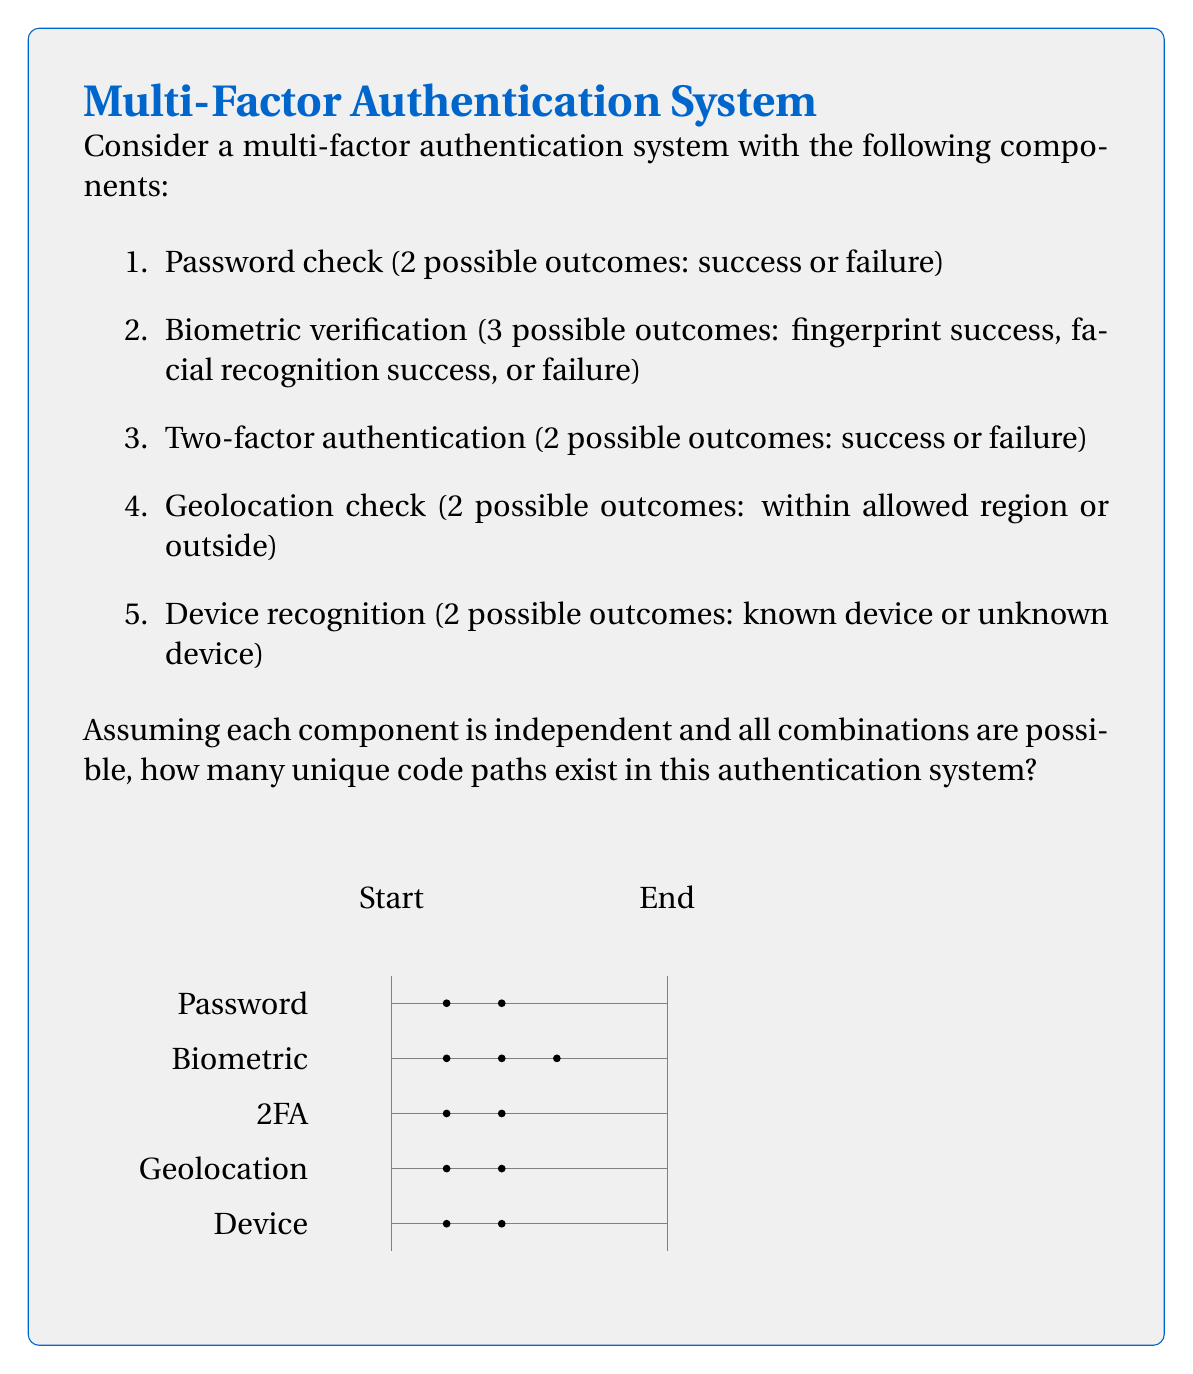Help me with this question. To solve this problem, we'll use the multiplication principle of combinatorics. Since each component is independent and all combinations are possible, we multiply the number of possible outcomes for each component:

1. Password check: 2 outcomes
2. Biometric verification: 3 outcomes
3. Two-factor authentication: 2 outcomes
4. Geolocation check: 2 outcomes
5. Device recognition: 2 outcomes

The total number of unique code paths is:

$$2 \times 3 \times 2 \times 2 \times 2 = 48$$

Let's break it down step-by-step:

1. Start with the password check: 2 possible paths
2. For each of those 2 paths, there are 3 biometric outcomes: $2 \times 3 = 6$ paths
3. For each of those 6 paths, there are 2 two-factor authentication outcomes: $6 \times 2 = 12$ paths
4. For each of those 12 paths, there are 2 geolocation outcomes: $12 \times 2 = 24$ paths
5. Finally, for each of those 24 paths, there are 2 device recognition outcomes: $24 \times 2 = 48$ paths

This approach ensures that we've considered all possible combinations of outcomes for each component, resulting in the total number of unique code paths through the authentication system.
Answer: 48 